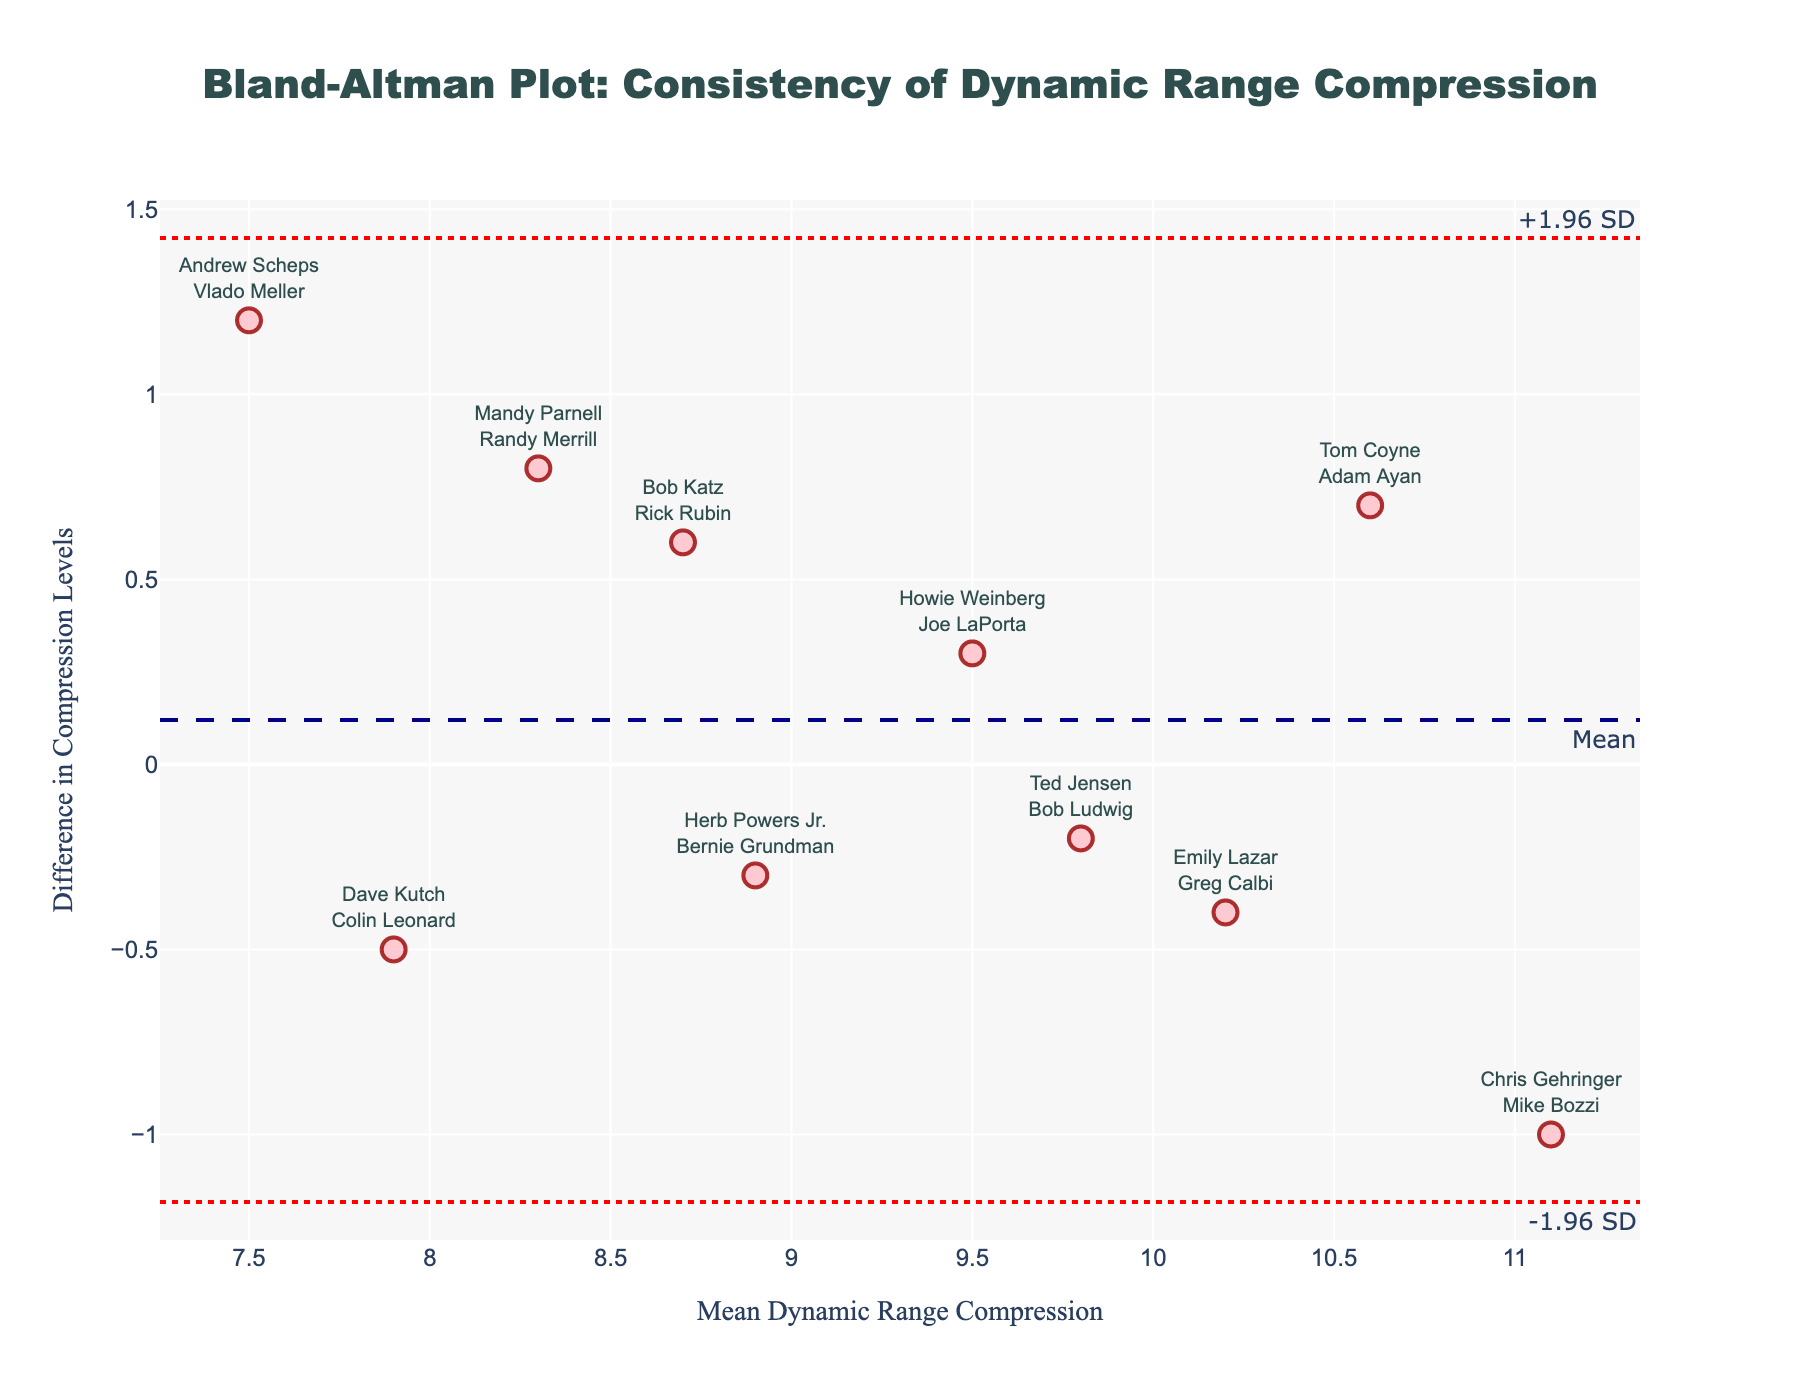What's the title of the plot? Look at the top of the figure to find the title text, which describes the purpose of the plot.
Answer: Bland-Altman Plot: Consistency of Dynamic Range Compression How many data points are represented in the plot? Count the number of individual markers on the plot. Each marker represents a specific pairing of engineers.
Answer: 10 What are the x-axis and y-axis titles? Observe the labels on both the horizontal (x-axis) and vertical (y-axis) sides of the plot.
Answer: x-axis: Mean Dynamic Range Compression; y-axis: Difference in Compression Levels Which engineer pairing has the highest positive difference in compression levels? Look for the marker that is positioned the highest (y-axis) and note the pairing of engineers corresponding to this point.
Answer: Andrew Scheps and Vlado Meller Which engineer pairing has the largest negative difference in compression levels? Identify the marker that is positioned the lowest (y-axis) and note the pairing of engineers corresponding to this point.
Answer: Chris Gehringer and Mike Bozzi What are the values of the upper and lower limits of agreement? Find the dashed lines representing the limits of agreement and check their corresponding y-values. These are usually annotated near the lines themselves.
Answer: Upper limit: 1.066; Lower limit: -0.846 Are all data points within the limits of agreement? Check if all markers fall between the upper and lower bounds (dashed lines) without crossing them.
Answer: Yes What is the mean difference in compression levels between the engineer pairings? Identify the mean difference horizontal line (usually labeled as "Mean") and note its y-value.
Answer: 0.11 Which pair of engineers have a mean compression level of around 10? Find the markers close to x=10 on the plot and read the labels to determine which pairs of engineers these markers represent.
Answer: Emily Lazar and Greg Calbi; Ted Jensen and Bob Ludwig; Tom Coyne and Adam Ayan Is there a noticeable trend or pattern in how differences in compression levels vary with the mean compression level? Observe the overall distribution of markers to identify any visible pattern, such as a consistent increase or decrease.
Answer: No clear trend, the differences appear randomly scattered 